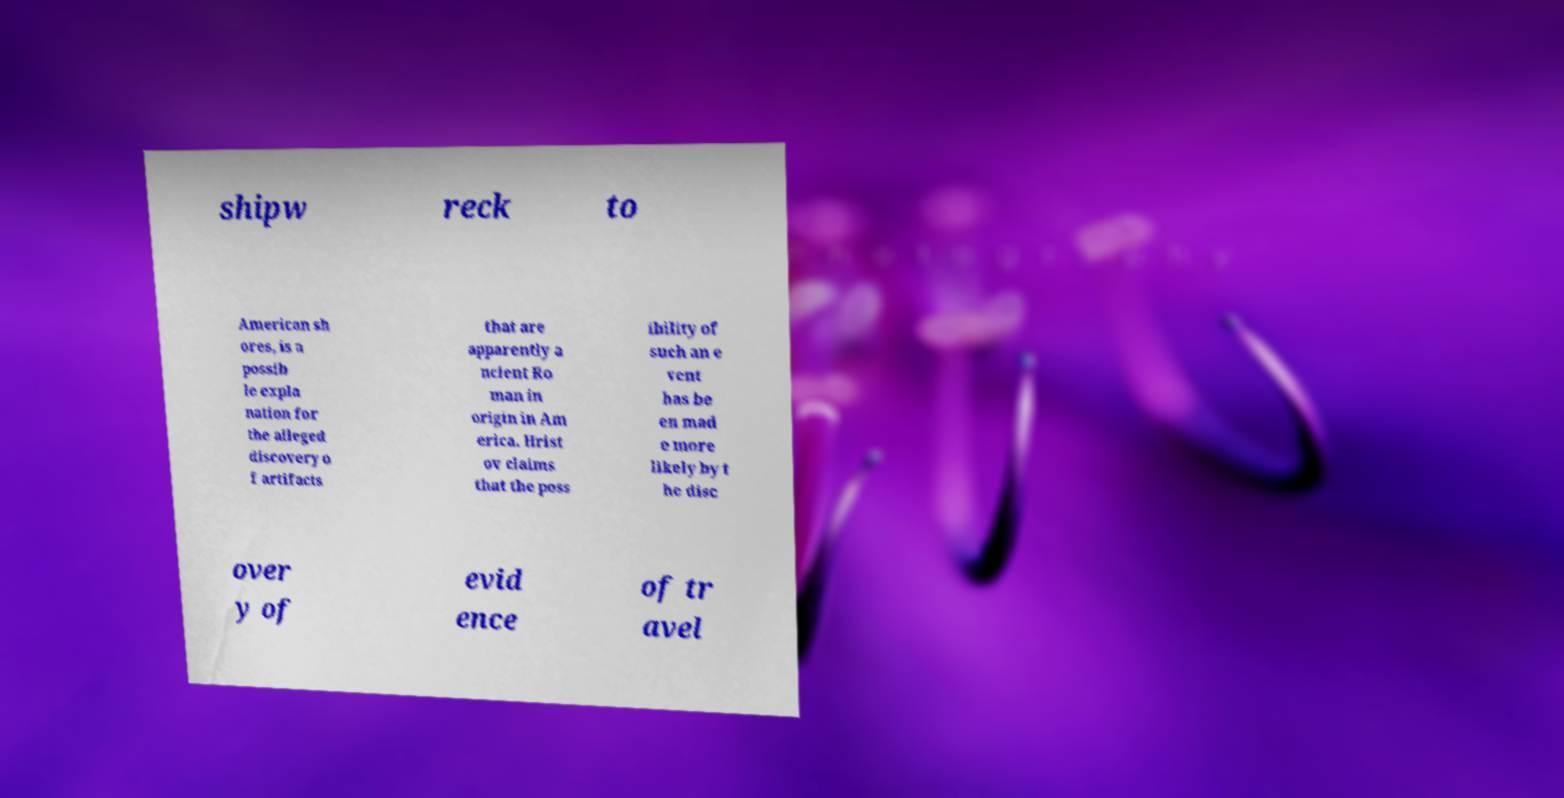Can you accurately transcribe the text from the provided image for me? shipw reck to American sh ores, is a possib le expla nation for the alleged discovery o f artifacts that are apparently a ncient Ro man in origin in Am erica. Hrist ov claims that the poss ibility of such an e vent has be en mad e more likely by t he disc over y of evid ence of tr avel 